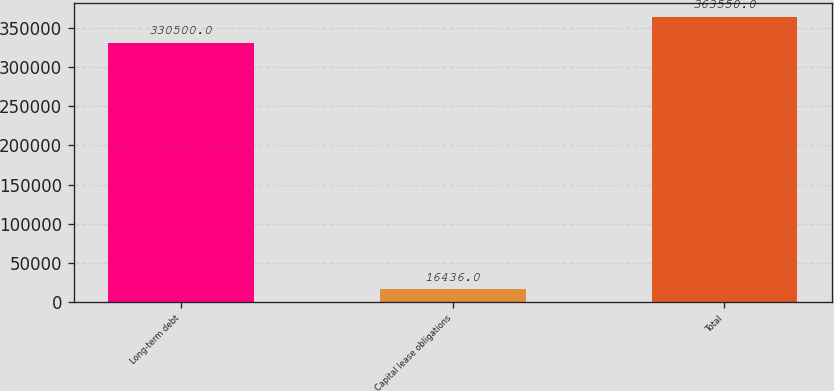Convert chart to OTSL. <chart><loc_0><loc_0><loc_500><loc_500><bar_chart><fcel>Long-term debt<fcel>Capital lease obligations<fcel>Total<nl><fcel>330500<fcel>16436<fcel>363550<nl></chart> 